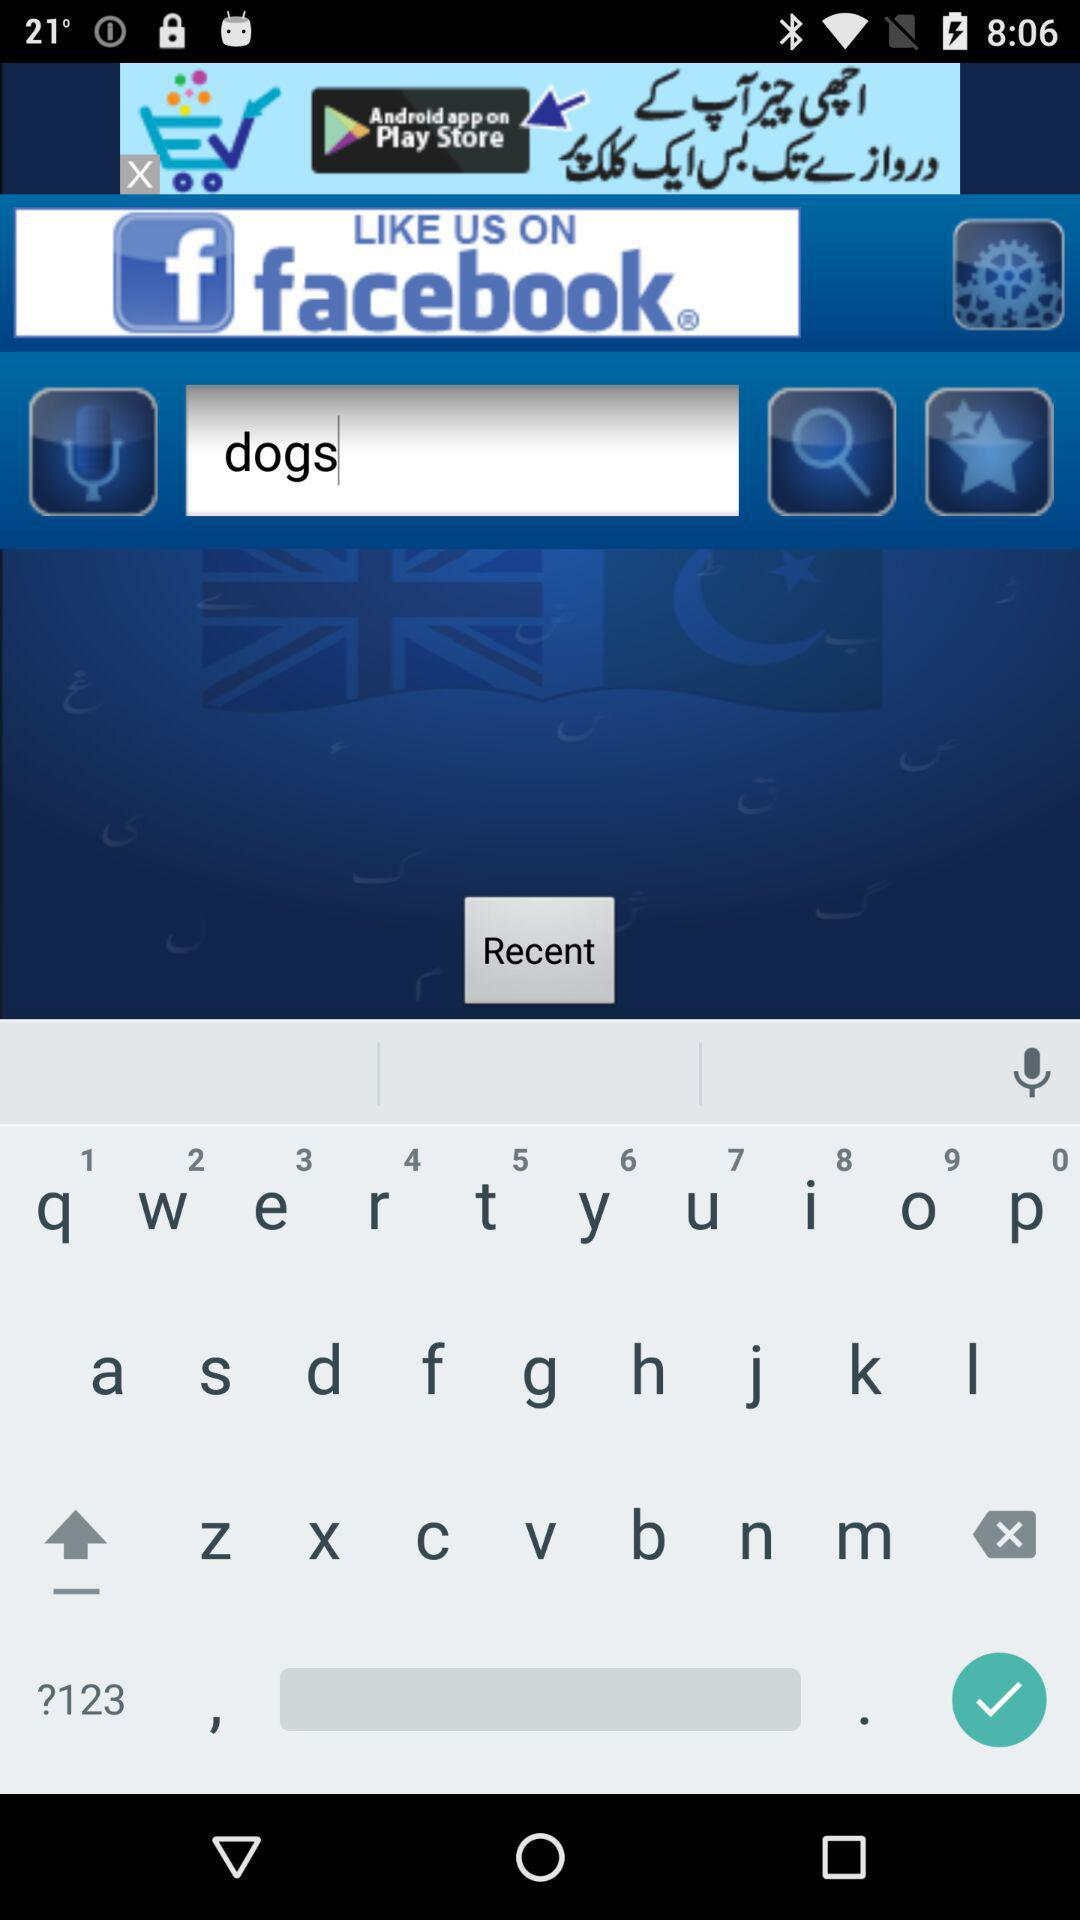What are the different wallpaper applications available? The different wallpaper applications that are available are "Hipster Wallpapers", "Teen Wallpapers", "Sassy Wallpapers", "Inspirational Wallpapers", "Psychedelic Wallpapers", "Lock Screen Wallpapers" and "Funny Wallpapers". 